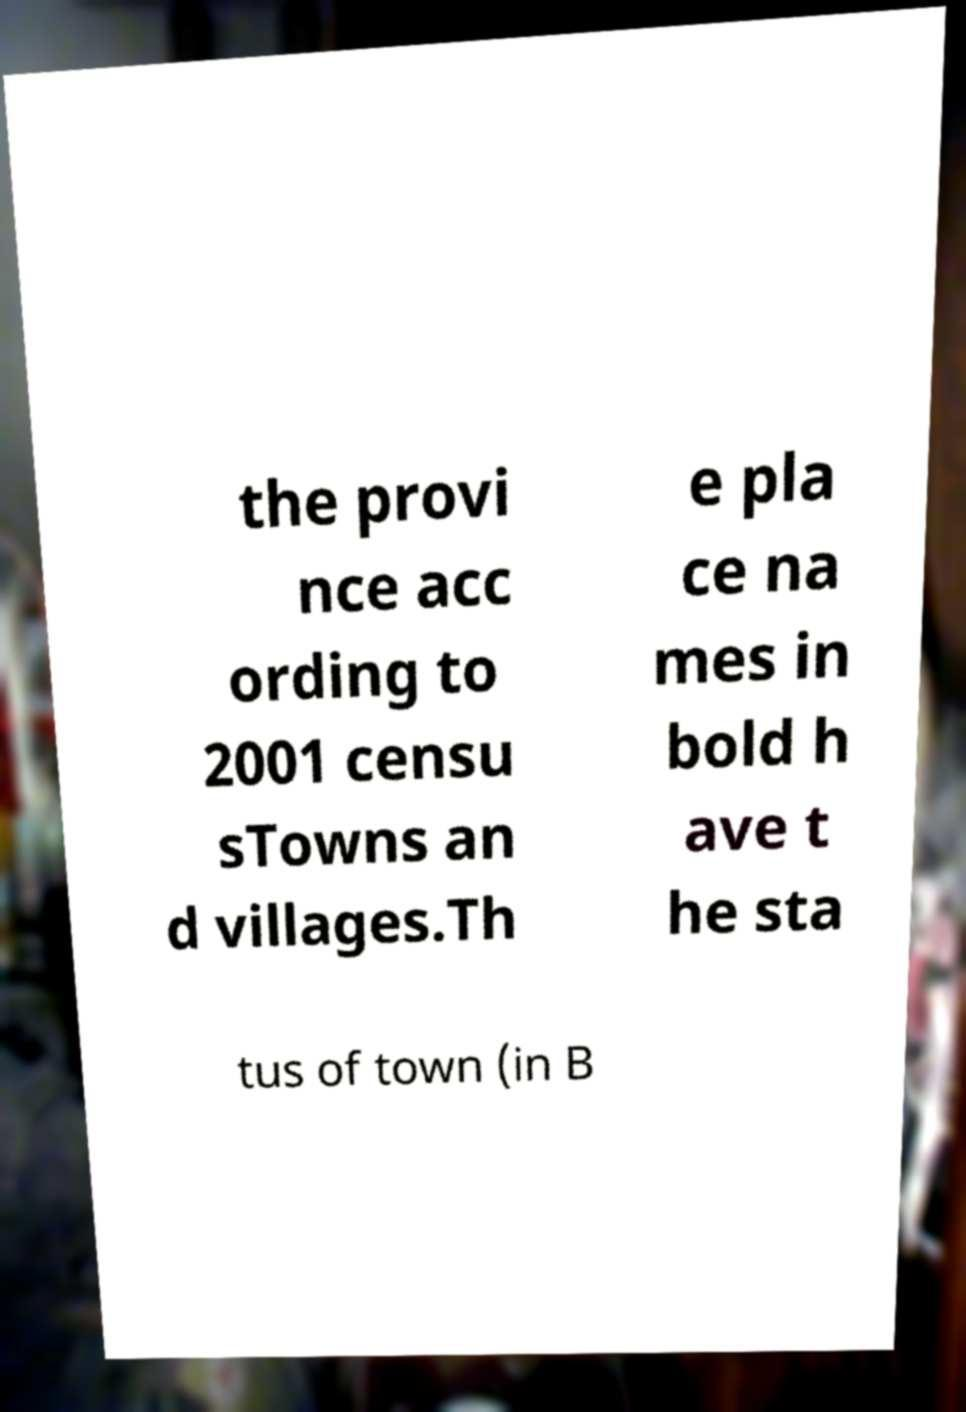Can you accurately transcribe the text from the provided image for me? the provi nce acc ording to 2001 censu sTowns an d villages.Th e pla ce na mes in bold h ave t he sta tus of town (in B 